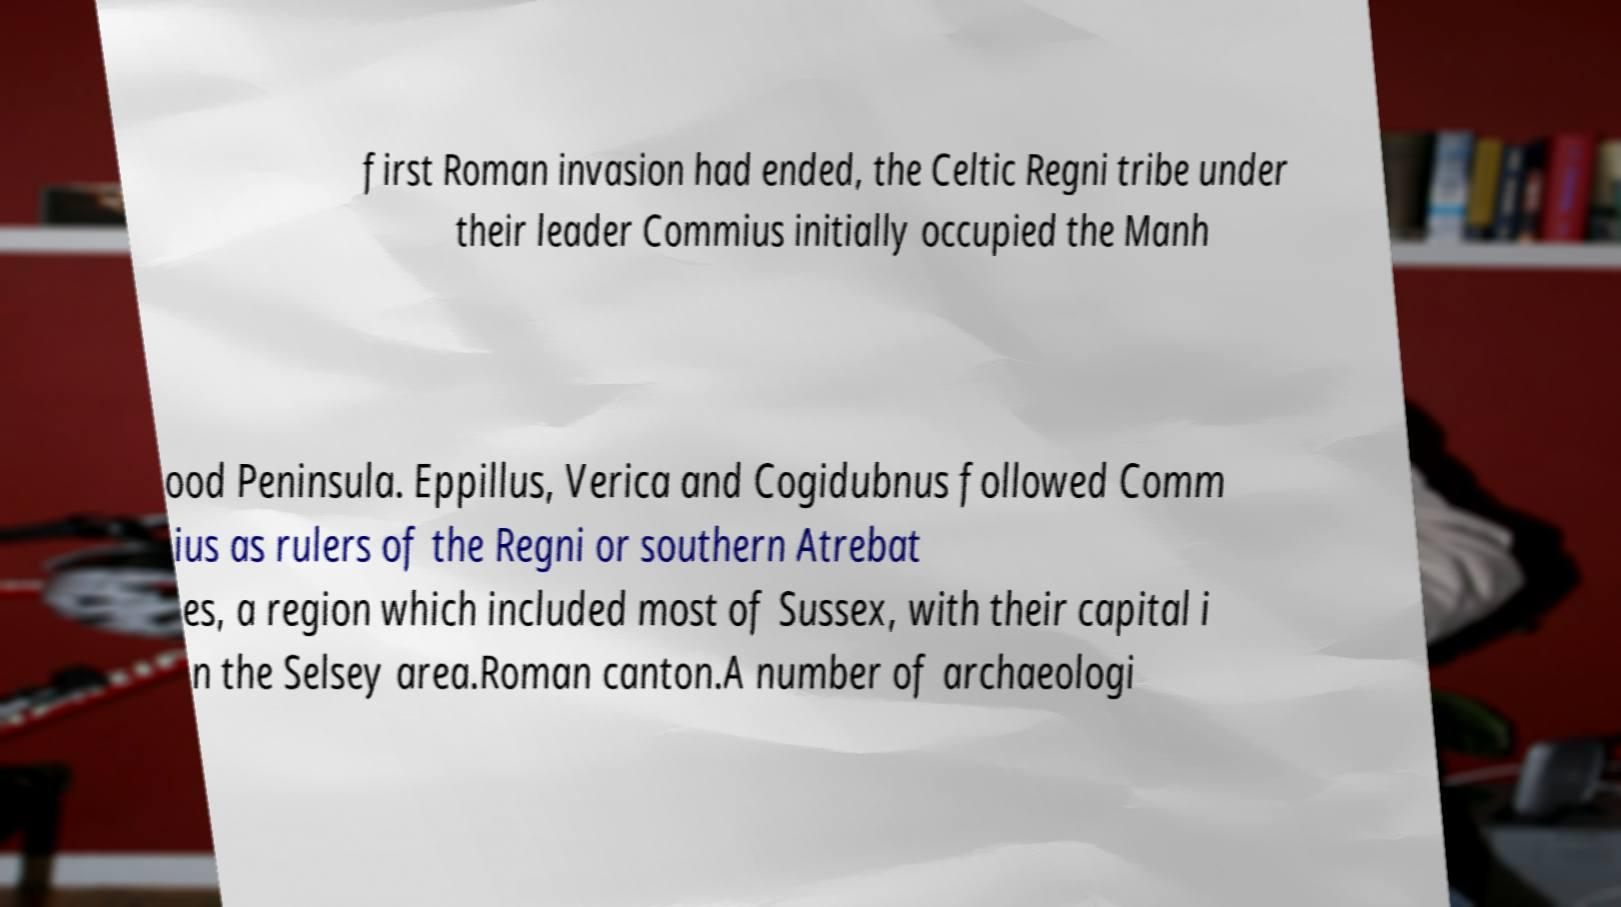Please identify and transcribe the text found in this image. first Roman invasion had ended, the Celtic Regni tribe under their leader Commius initially occupied the Manh ood Peninsula. Eppillus, Verica and Cogidubnus followed Comm ius as rulers of the Regni or southern Atrebat es, a region which included most of Sussex, with their capital i n the Selsey area.Roman canton.A number of archaeologi 